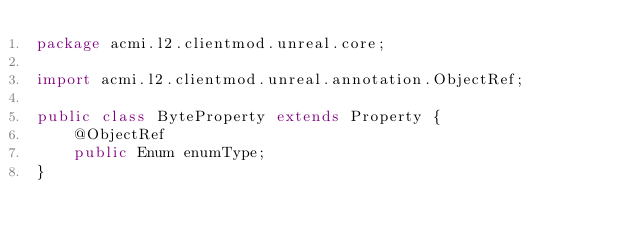<code> <loc_0><loc_0><loc_500><loc_500><_Java_>package acmi.l2.clientmod.unreal.core;

import acmi.l2.clientmod.unreal.annotation.ObjectRef;

public class ByteProperty extends Property {
    @ObjectRef
    public Enum enumType;
}
</code> 